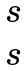Convert formula to latex. <formula><loc_0><loc_0><loc_500><loc_500>\begin{matrix} s \\ s \end{matrix}</formula> 